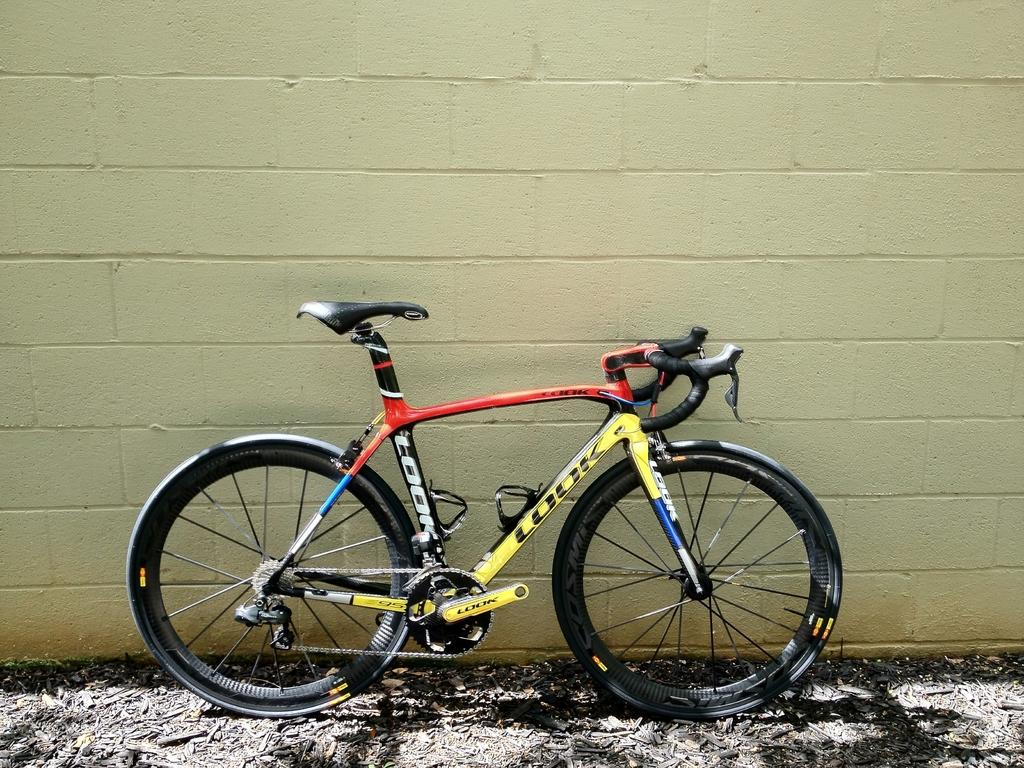What is the main object in the image? There is a bicycle in the image. Where is the bicycle located? The bicycle is on a path. What can be seen behind the bicycle? There is a wall behind the bicycle. What type of wax can be seen dripping from the sheet in the image? There is no sheet or wax present in the image; it features a bicycle on a path with a wall in the background. 